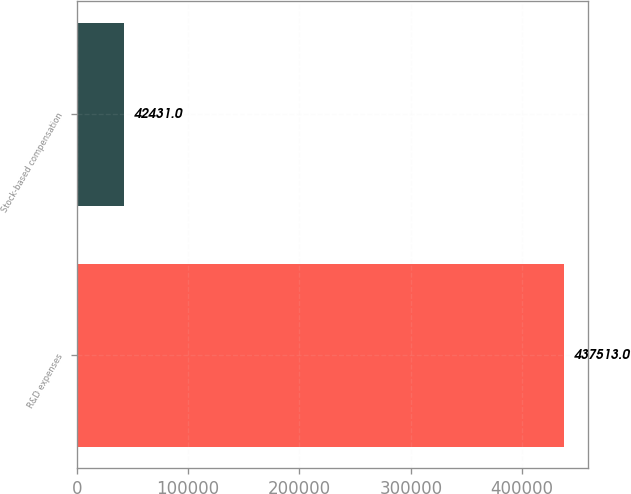Convert chart to OTSL. <chart><loc_0><loc_0><loc_500><loc_500><bar_chart><fcel>R&D expenses<fcel>Stock-based compensation<nl><fcel>437513<fcel>42431<nl></chart> 